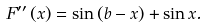Convert formula to latex. <formula><loc_0><loc_0><loc_500><loc_500>F ^ { \prime \prime } \left ( x \right ) = \sin \left ( b - x \right ) + \sin x .</formula> 